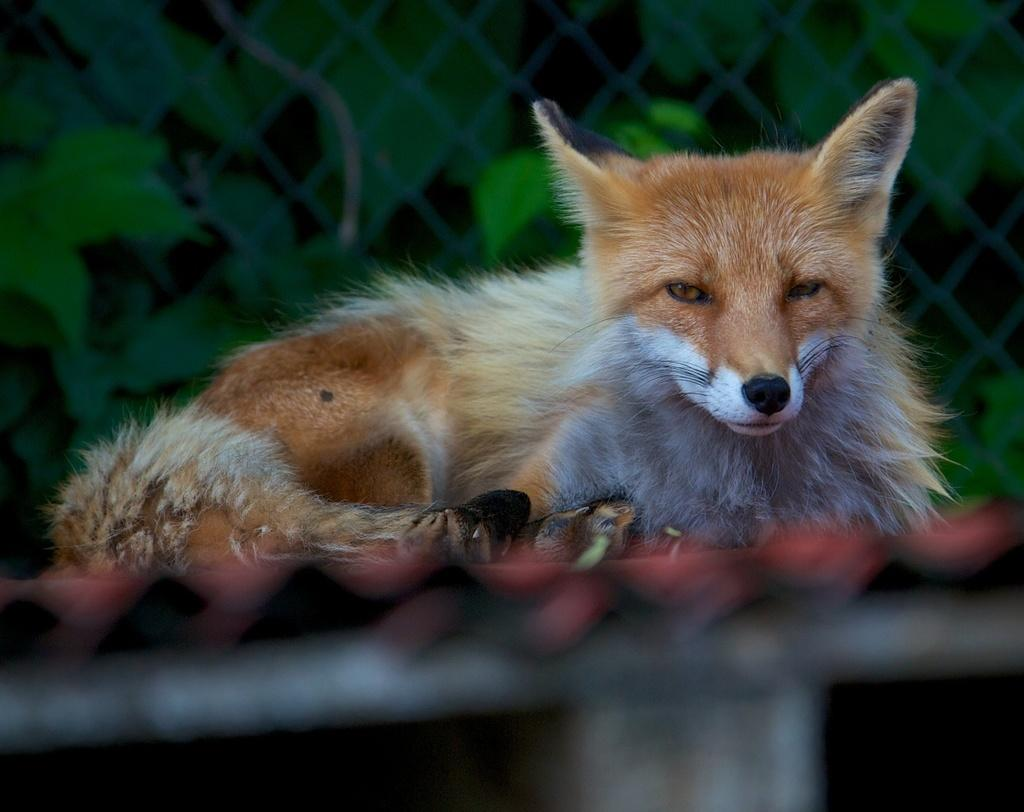What type of animal is present in the image? There is a dog in the image. What is located behind the dog in the image? There is a fence visible behind the dog. What type of flowers can be seen growing on the dog in the image? There are no flowers present on the dog in the image. 